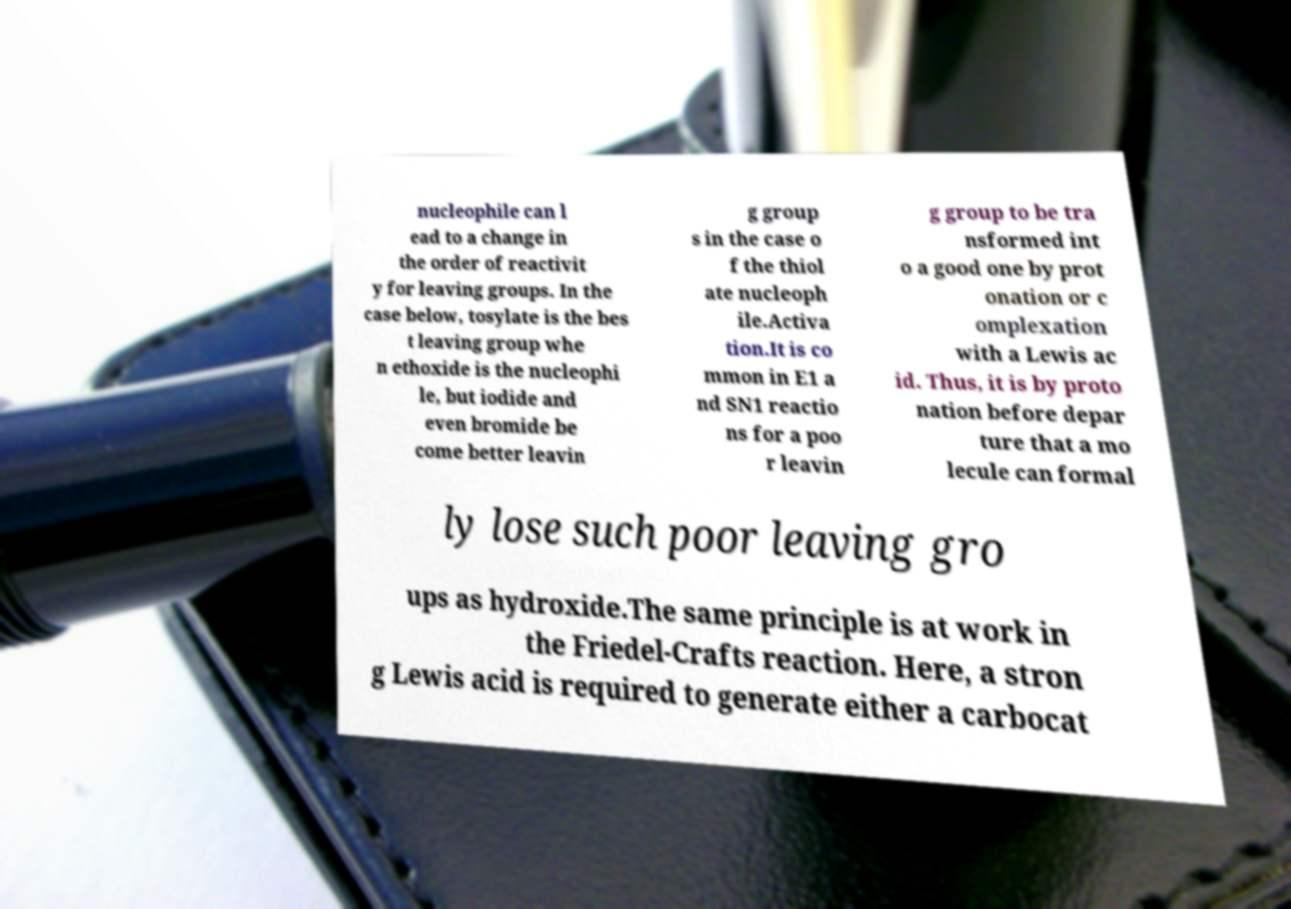There's text embedded in this image that I need extracted. Can you transcribe it verbatim? nucleophile can l ead to a change in the order of reactivit y for leaving groups. In the case below, tosylate is the bes t leaving group whe n ethoxide is the nucleophi le, but iodide and even bromide be come better leavin g group s in the case o f the thiol ate nucleoph ile.Activa tion.It is co mmon in E1 a nd SN1 reactio ns for a poo r leavin g group to be tra nsformed int o a good one by prot onation or c omplexation with a Lewis ac id. Thus, it is by proto nation before depar ture that a mo lecule can formal ly lose such poor leaving gro ups as hydroxide.The same principle is at work in the Friedel-Crafts reaction. Here, a stron g Lewis acid is required to generate either a carbocat 